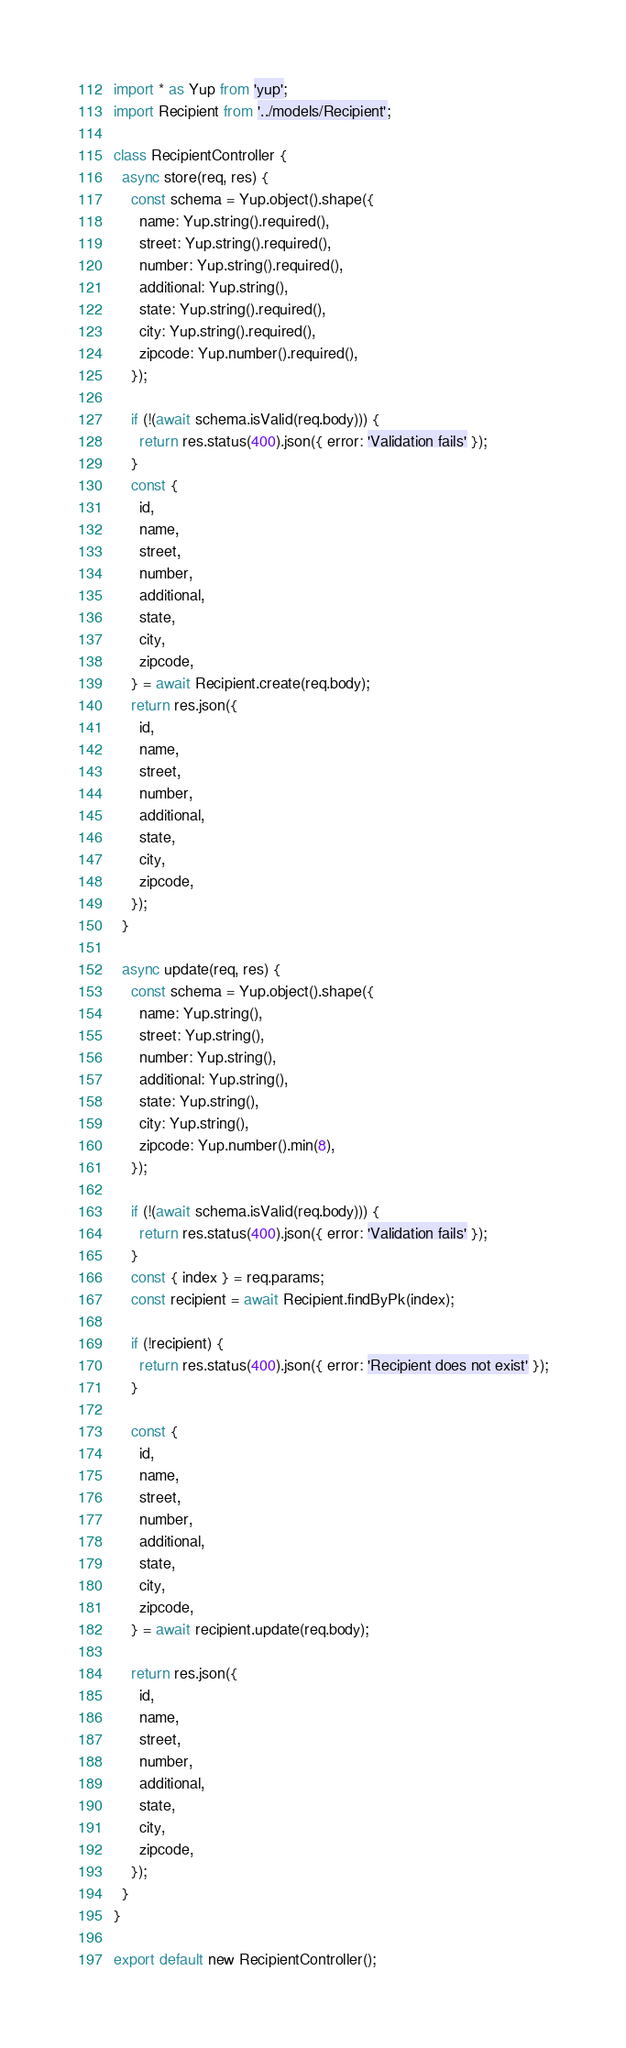Convert code to text. <code><loc_0><loc_0><loc_500><loc_500><_JavaScript_>import * as Yup from 'yup';
import Recipient from '../models/Recipient';

class RecipientController {
  async store(req, res) {
    const schema = Yup.object().shape({
      name: Yup.string().required(),
      street: Yup.string().required(),
      number: Yup.string().required(),
      additional: Yup.string(),
      state: Yup.string().required(),
      city: Yup.string().required(),
      zipcode: Yup.number().required(),
    });

    if (!(await schema.isValid(req.body))) {
      return res.status(400).json({ error: 'Validation fails' });
    }
    const {
      id,
      name,
      street,
      number,
      additional,
      state,
      city,
      zipcode,
    } = await Recipient.create(req.body);
    return res.json({
      id,
      name,
      street,
      number,
      additional,
      state,
      city,
      zipcode,
    });
  }

  async update(req, res) {
    const schema = Yup.object().shape({
      name: Yup.string(),
      street: Yup.string(),
      number: Yup.string(),
      additional: Yup.string(),
      state: Yup.string(),
      city: Yup.string(),
      zipcode: Yup.number().min(8),
    });

    if (!(await schema.isValid(req.body))) {
      return res.status(400).json({ error: 'Validation fails' });
    }
    const { index } = req.params;
    const recipient = await Recipient.findByPk(index);

    if (!recipient) {
      return res.status(400).json({ error: 'Recipient does not exist' });
    }

    const {
      id,
      name,
      street,
      number,
      additional,
      state,
      city,
      zipcode,
    } = await recipient.update(req.body);

    return res.json({
      id,
      name,
      street,
      number,
      additional,
      state,
      city,
      zipcode,
    });
  }
}

export default new RecipientController();
</code> 